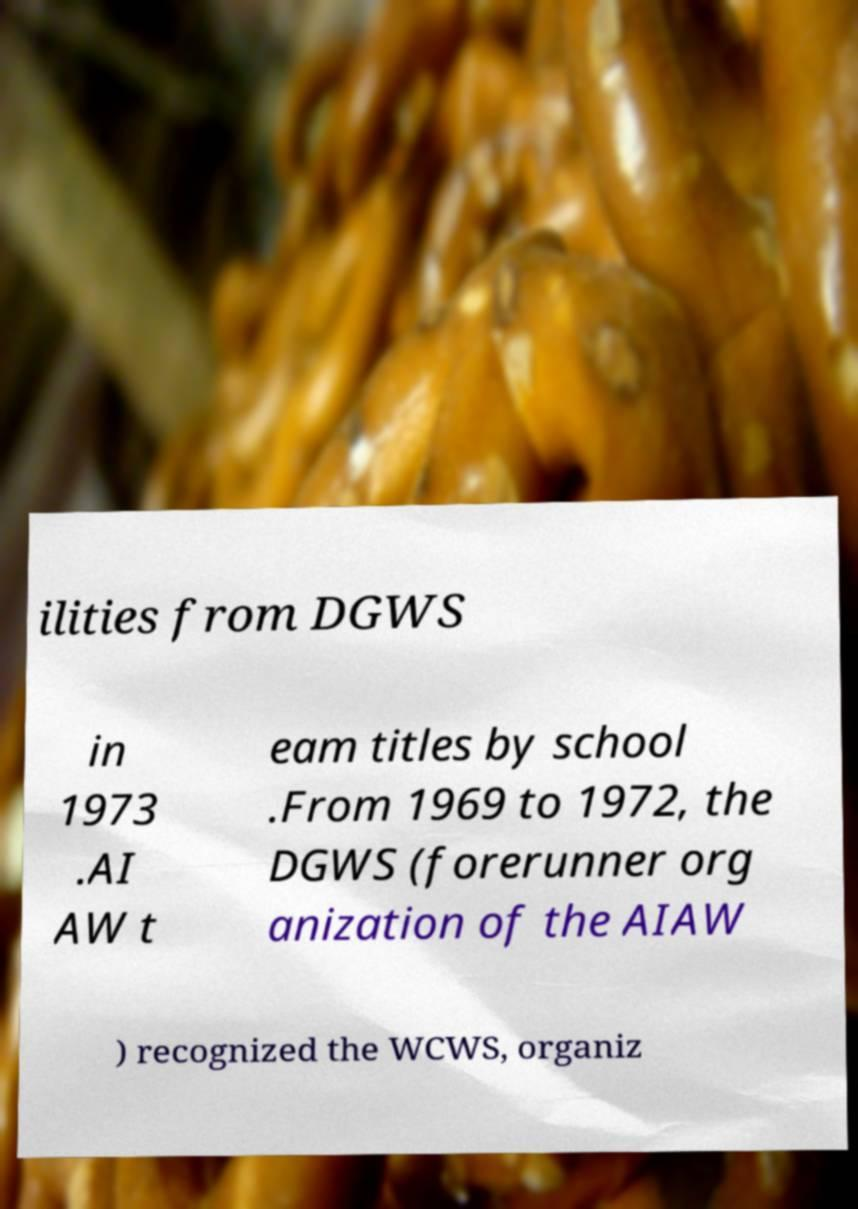There's text embedded in this image that I need extracted. Can you transcribe it verbatim? ilities from DGWS in 1973 .AI AW t eam titles by school .From 1969 to 1972, the DGWS (forerunner org anization of the AIAW ) recognized the WCWS, organiz 